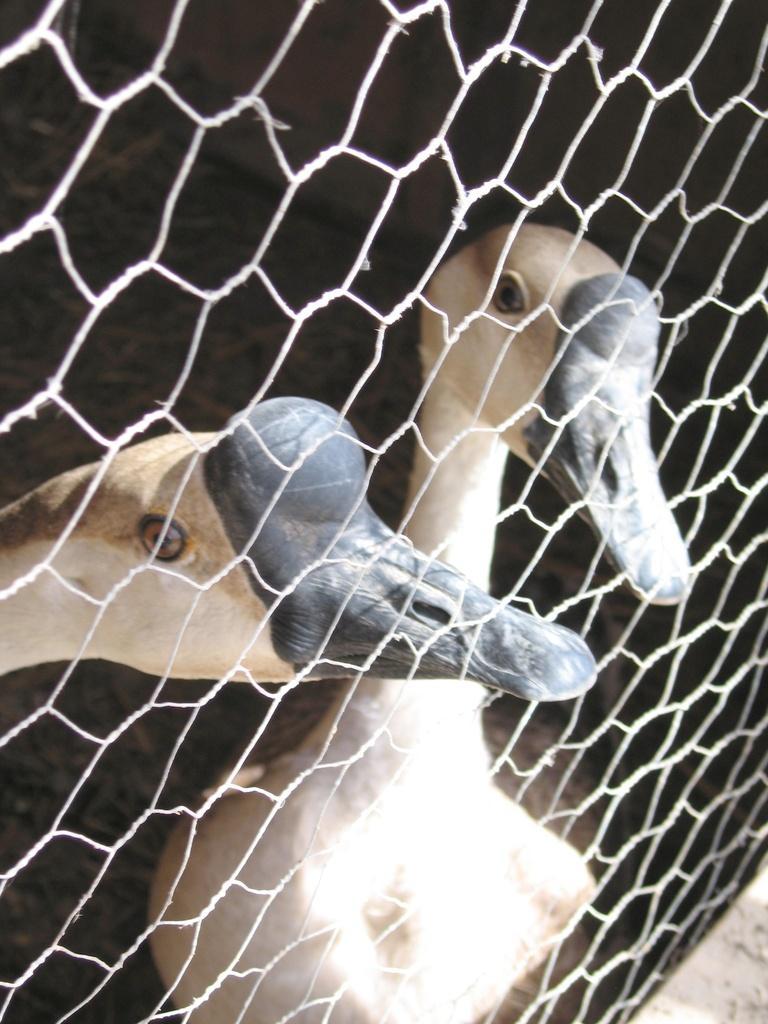Can you describe this image briefly? There are two ducks present behind to a white color net as we can see in the middle of this image. 